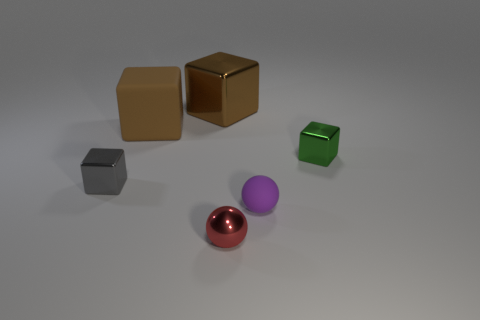How many green cubes are behind the tiny green metal thing?
Keep it short and to the point. 0. Are there an equal number of brown matte things that are to the left of the brown matte cube and small spheres that are in front of the tiny gray shiny block?
Ensure brevity in your answer.  No. What size is the brown metal object that is the same shape as the brown matte object?
Your answer should be very brief. Large. What shape is the metal thing that is in front of the small gray metal object?
Your response must be concise. Sphere. Is the block that is in front of the tiny green metal cube made of the same material as the cube that is on the right side of the purple sphere?
Your response must be concise. Yes. The tiny red object is what shape?
Your response must be concise. Sphere. Are there an equal number of green shiny objects that are to the right of the purple matte thing and small red metal spheres?
Ensure brevity in your answer.  Yes. What is the size of the matte thing that is the same color as the big metal block?
Your response must be concise. Large. Are there any cylinders made of the same material as the small green cube?
Give a very brief answer. No. There is a matte object to the left of the tiny rubber thing; does it have the same shape as the brown thing that is behind the big rubber thing?
Provide a short and direct response. Yes. 